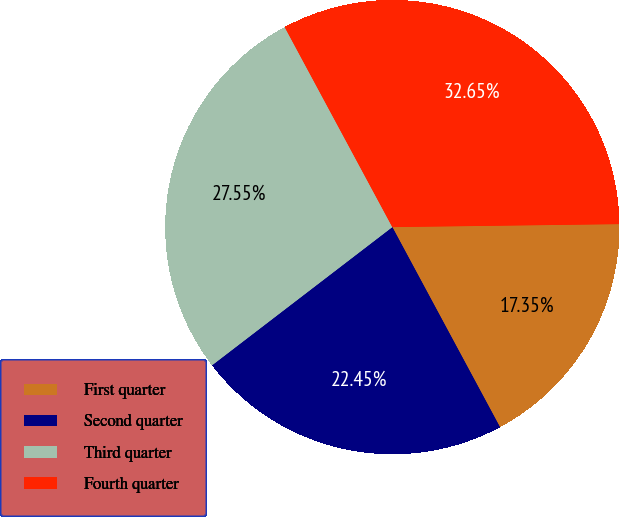Convert chart. <chart><loc_0><loc_0><loc_500><loc_500><pie_chart><fcel>First quarter<fcel>Second quarter<fcel>Third quarter<fcel>Fourth quarter<nl><fcel>17.35%<fcel>22.45%<fcel>27.55%<fcel>32.65%<nl></chart> 